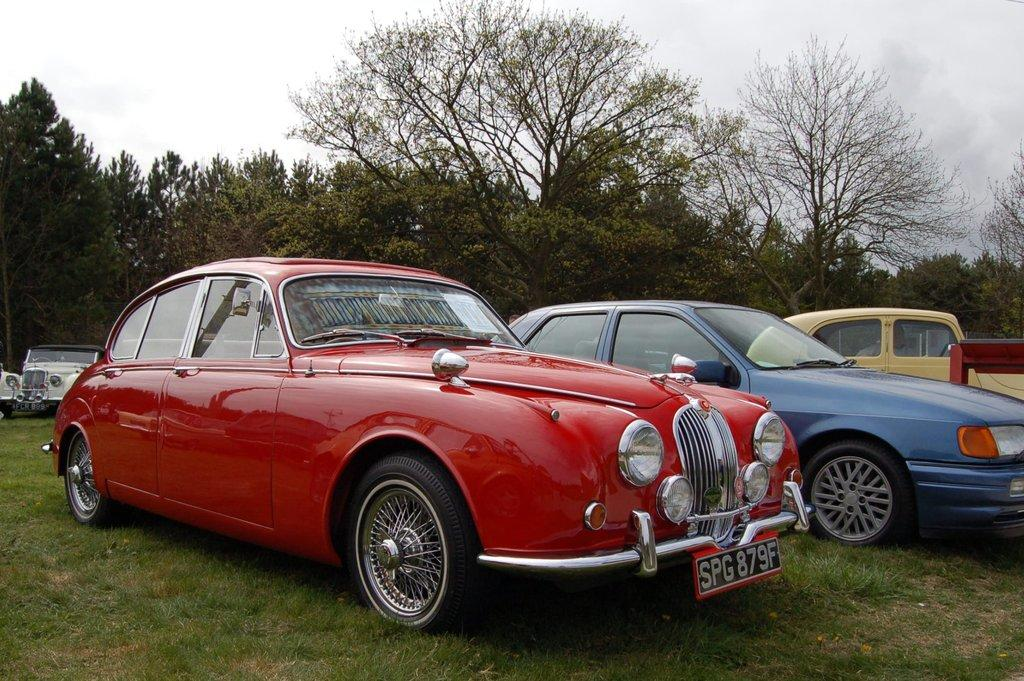What types of objects are on the ground in the image? There are vehicles on the ground in the image. What is the ground covered with? The ground is covered with grass. What else can be seen in the image besides the vehicles and grass? There are trees visible in the image. What is visible above the trees and vehicles in the image? The sky is visible in the image, and clouds are present in the sky. Where are the books located in the image? There are no books present in the image. What type of bushes can be seen growing near the vehicles in the image? There are no bushes visible in the image; it only shows vehicles, grass, trees, and the sky. 